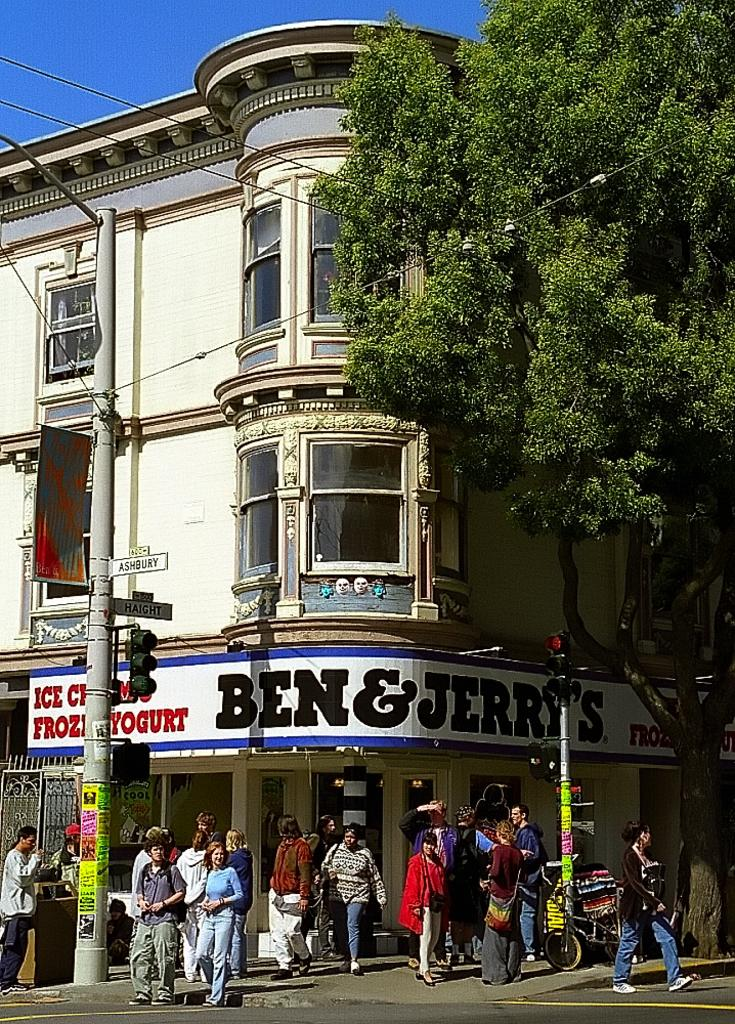<image>
Describe the image concisely. A number of people mill about a street corner on a sunny day in front of a Ben and Jerry's store. 